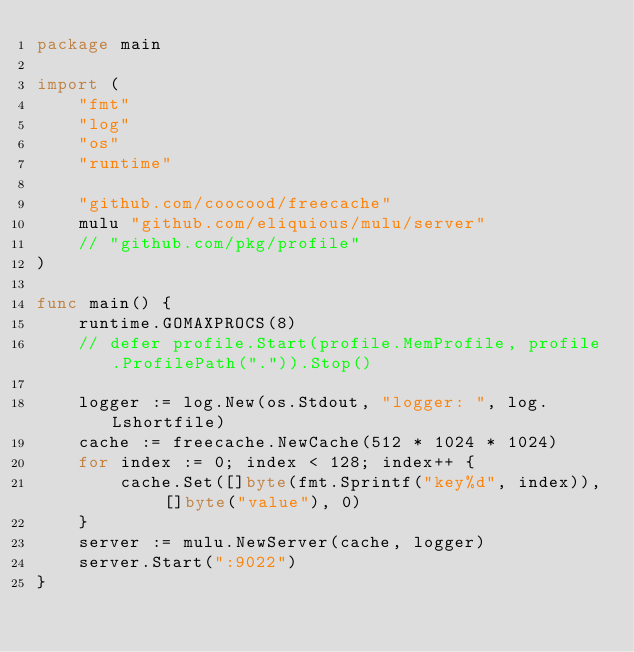Convert code to text. <code><loc_0><loc_0><loc_500><loc_500><_Go_>package main

import (
	"fmt"
	"log"
	"os"
	"runtime"

	"github.com/coocood/freecache"
	mulu "github.com/eliquious/mulu/server"
	// "github.com/pkg/profile"
)

func main() {
	runtime.GOMAXPROCS(8)
	// defer profile.Start(profile.MemProfile, profile.ProfilePath(".")).Stop()

	logger := log.New(os.Stdout, "logger: ", log.Lshortfile)
	cache := freecache.NewCache(512 * 1024 * 1024)
	for index := 0; index < 128; index++ {
		cache.Set([]byte(fmt.Sprintf("key%d", index)), []byte("value"), 0)
	}
	server := mulu.NewServer(cache, logger)
	server.Start(":9022")
}
</code> 